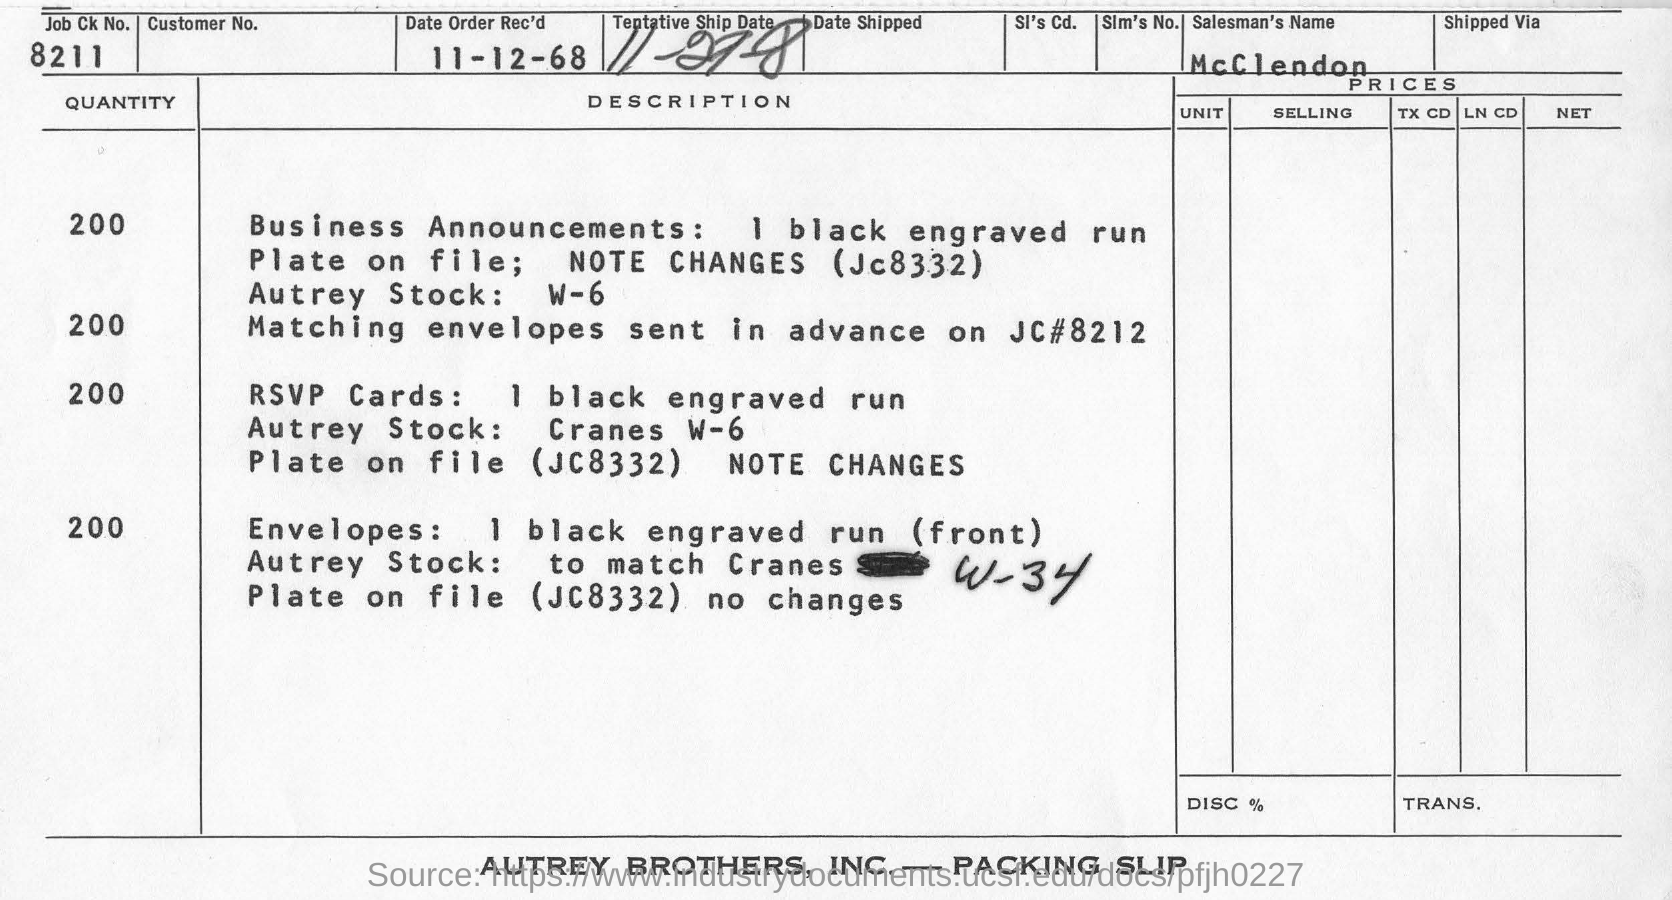Give some essential details in this illustration. The name of the Salesman is McClendon. The job number is 8211.. The date of the order received is November 12, 1968. 